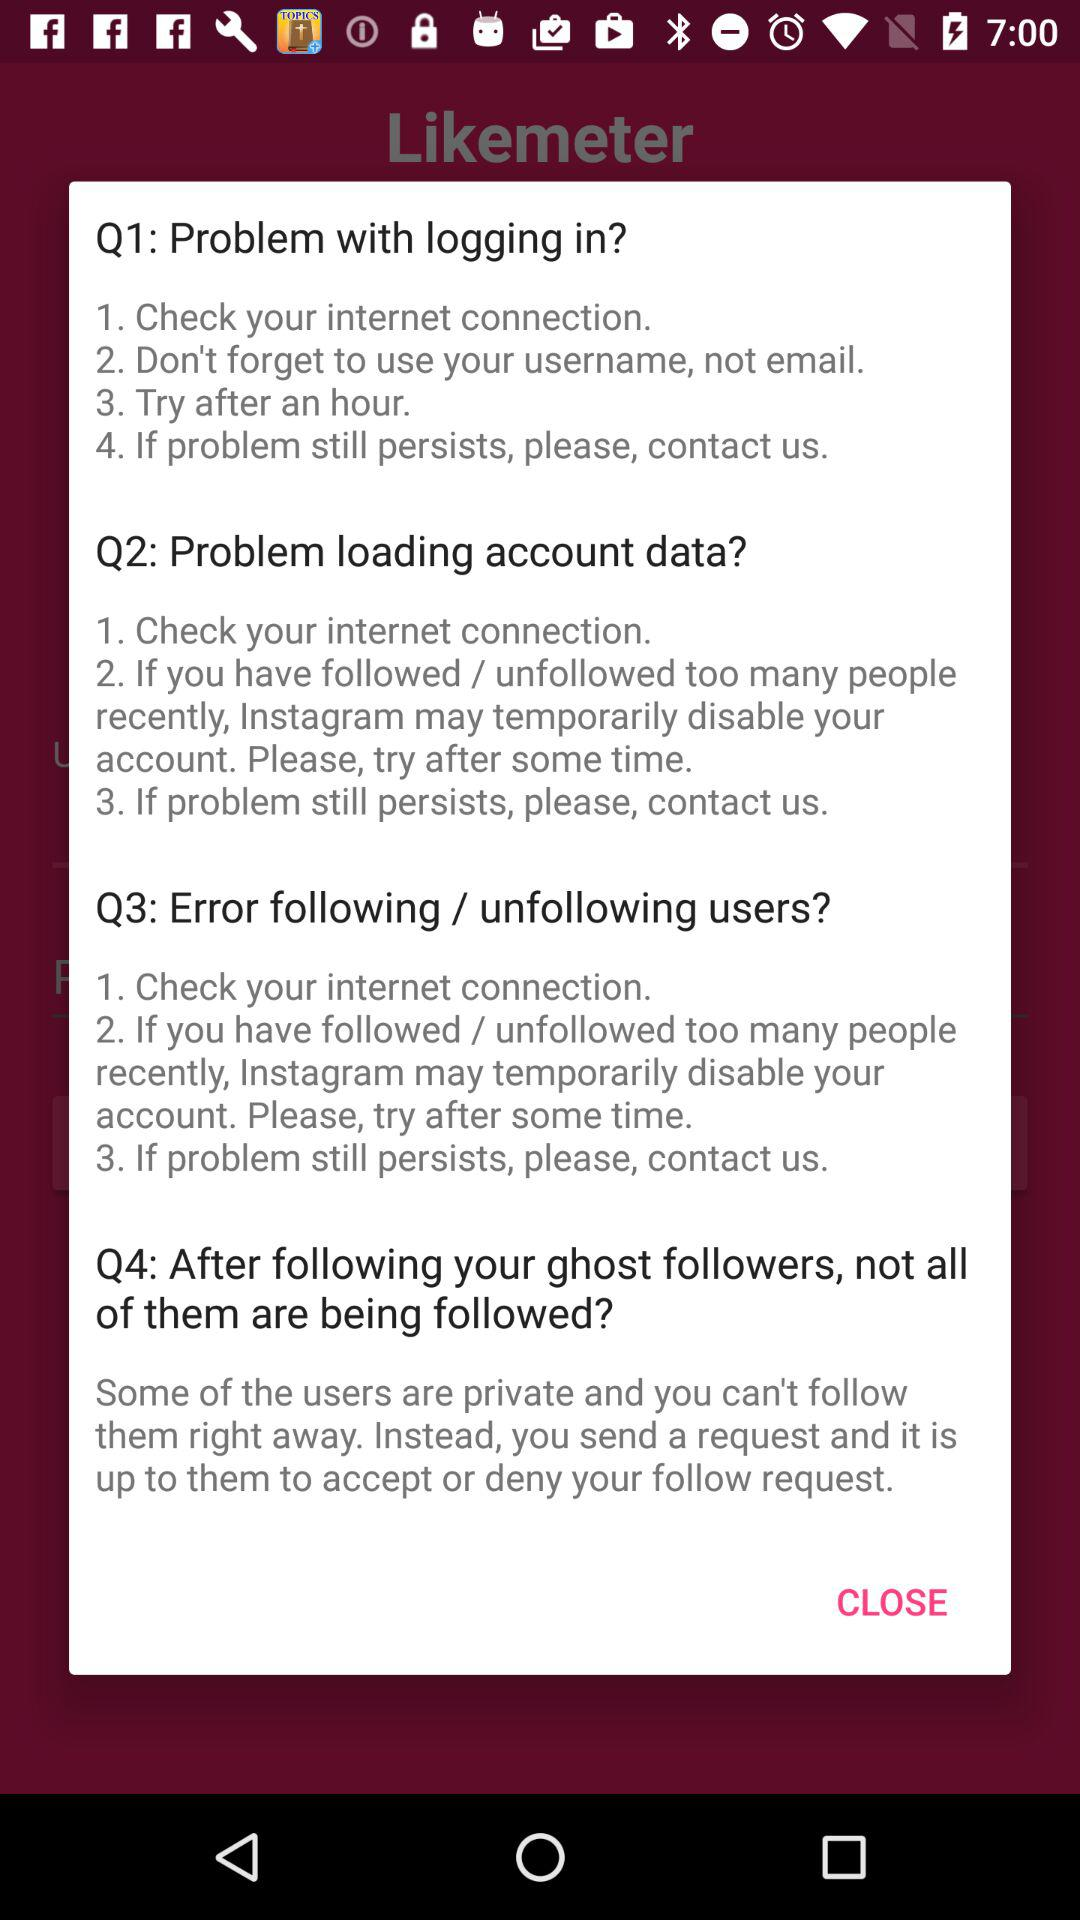How many troubleshooting tips are there for problem with logging in?
Answer the question using a single word or phrase. 4 